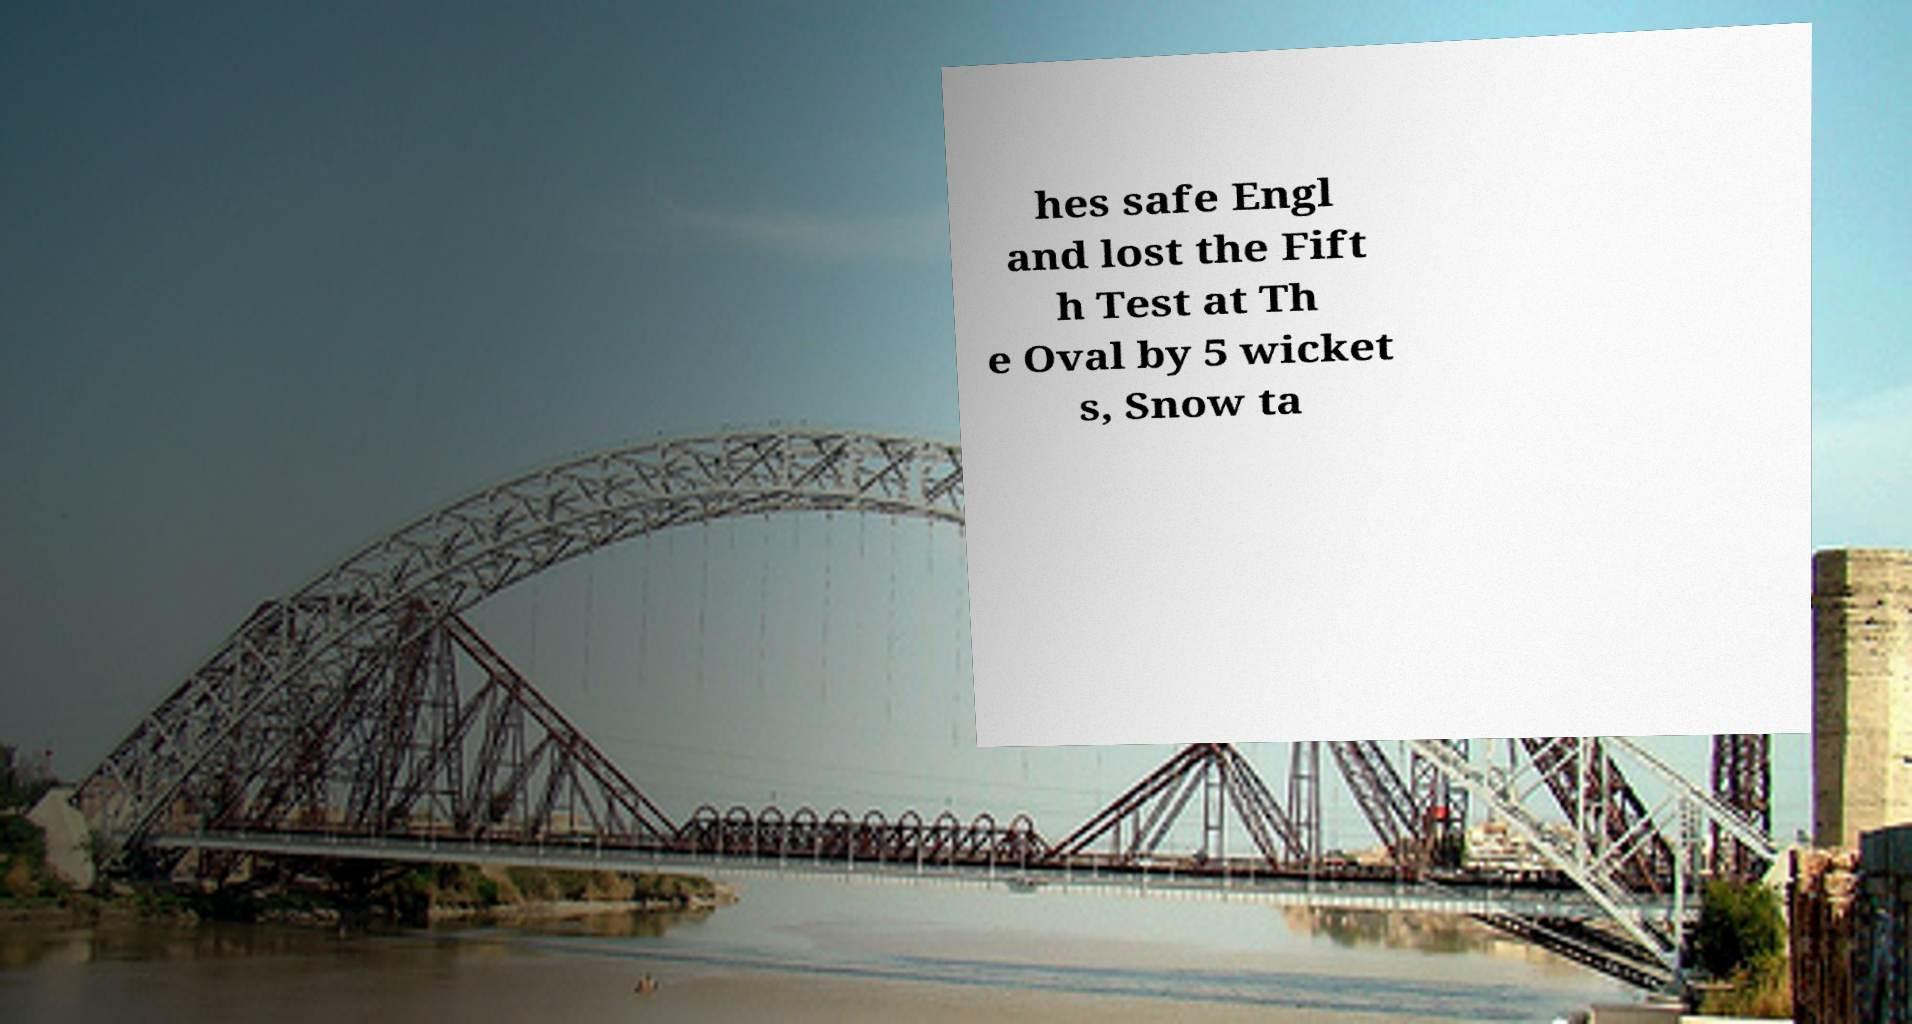Can you read and provide the text displayed in the image?This photo seems to have some interesting text. Can you extract and type it out for me? hes safe Engl and lost the Fift h Test at Th e Oval by 5 wicket s, Snow ta 